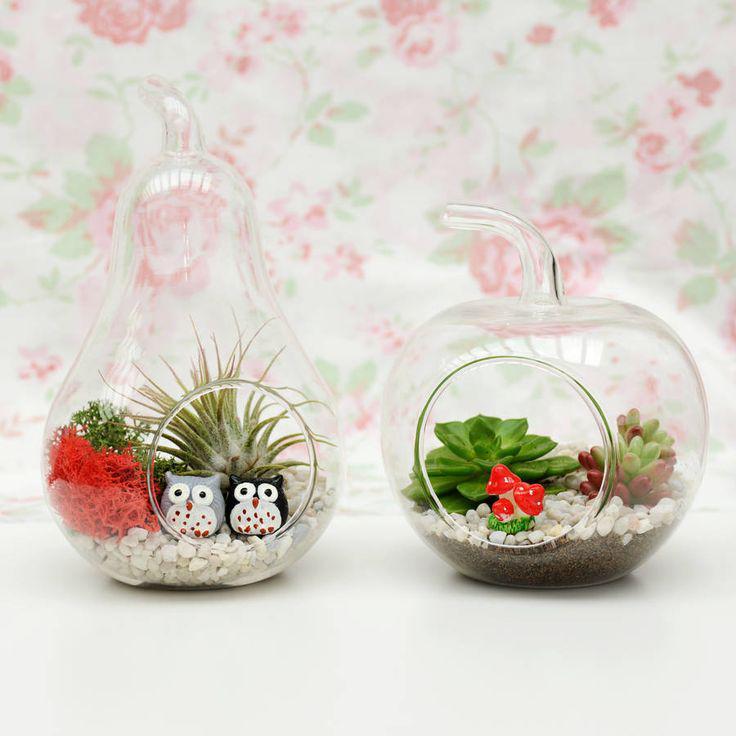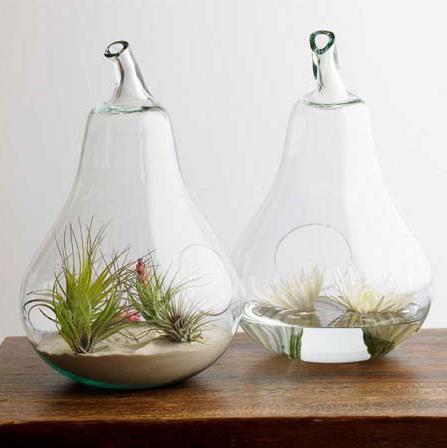The first image is the image on the left, the second image is the image on the right. For the images displayed, is the sentence "Each image contains side-by-side terrariums in fruit shapes that rest on a surface, and the combined images include at least two pear shapes and one apple shape." factually correct? Answer yes or no. Yes. The first image is the image on the left, the second image is the image on the right. Evaluate the accuracy of this statement regarding the images: "A single terrarium shaped like a pear sits on a surface in the image on the left.". Is it true? Answer yes or no. No. 